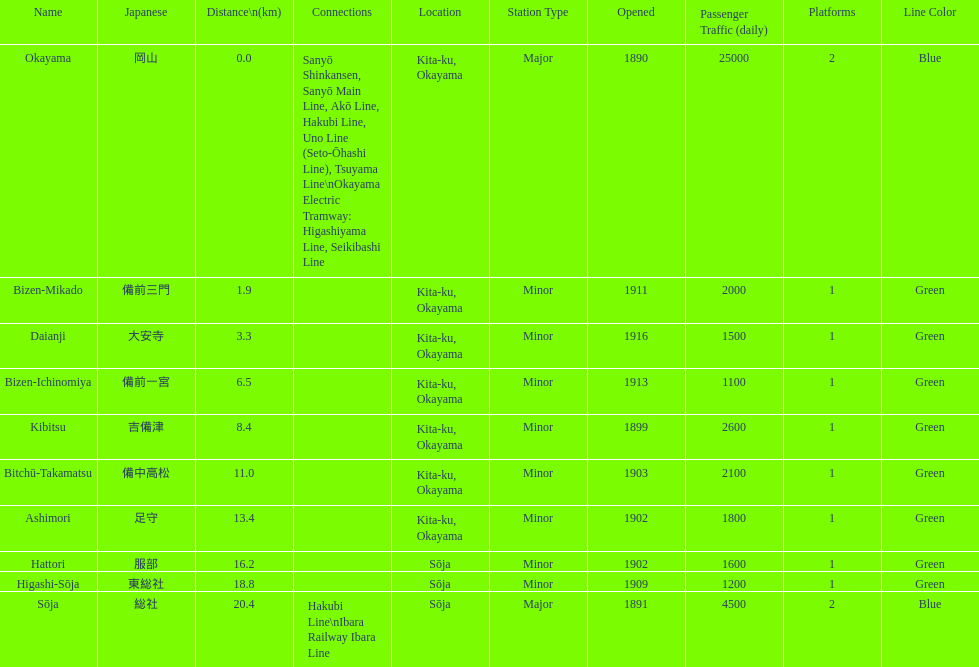How many stations have a distance below 15km? 7. 